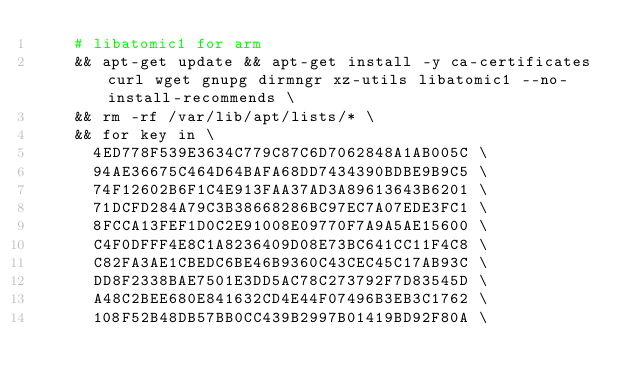Convert code to text. <code><loc_0><loc_0><loc_500><loc_500><_Dockerfile_>    # libatomic1 for arm
    && apt-get update && apt-get install -y ca-certificates curl wget gnupg dirmngr xz-utils libatomic1 --no-install-recommends \
    && rm -rf /var/lib/apt/lists/* \
    && for key in \
      4ED778F539E3634C779C87C6D7062848A1AB005C \
      94AE36675C464D64BAFA68DD7434390BDBE9B9C5 \
      74F12602B6F1C4E913FAA37AD3A89613643B6201 \
      71DCFD284A79C3B38668286BC97EC7A07EDE3FC1 \
      8FCCA13FEF1D0C2E91008E09770F7A9A5AE15600 \
      C4F0DFFF4E8C1A8236409D08E73BC641CC11F4C8 \
      C82FA3AE1CBEDC6BE46B9360C43CEC45C17AB93C \
      DD8F2338BAE7501E3DD5AC78C273792F7D83545D \
      A48C2BEE680E841632CD4E44F07496B3EB3C1762 \
      108F52B48DB57BB0CC439B2997B01419BD92F80A \</code> 